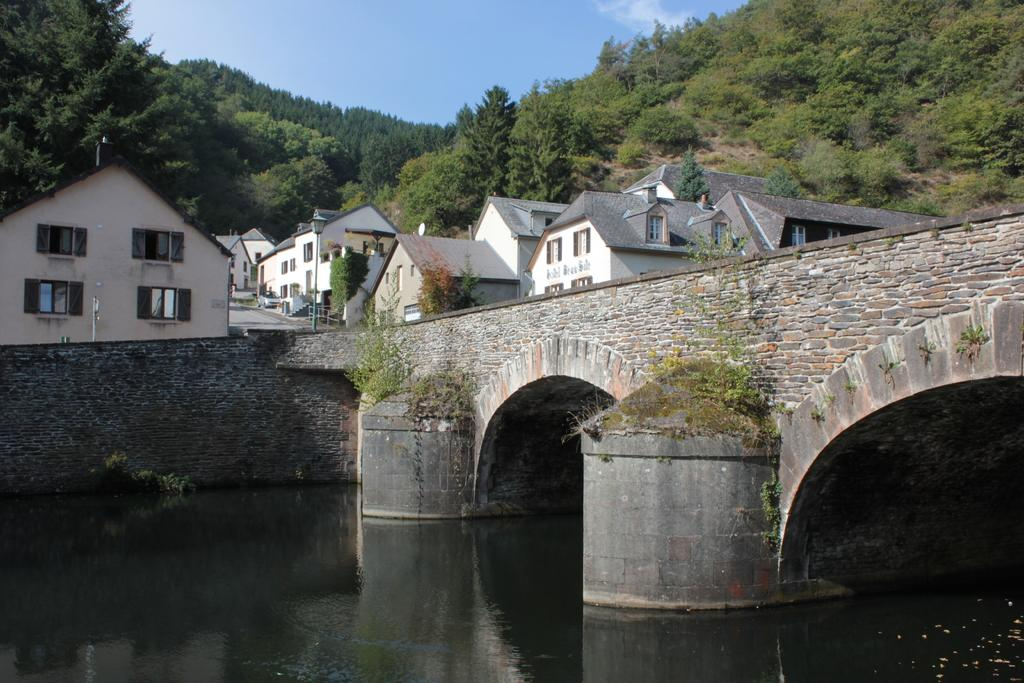What type of natural feature is present in the image? There is a river in the image. How is the river situated in relation to the bridge or tunnel? The river is under a bridge or tunnel. What can be seen outside the bridge in the image? There are houses outside the bridge. What type of vegetation surrounds the houses? The houses are surrounded by trees. What type of landscape can be seen in the distance? There are mountains visible in the image. What is the color of the sky in the image? The sky is blue in the image. Can you see a squirrel swimming in the river in the image? There is no squirrel visible in the image, and no indication that any animals are swimming in the river. 